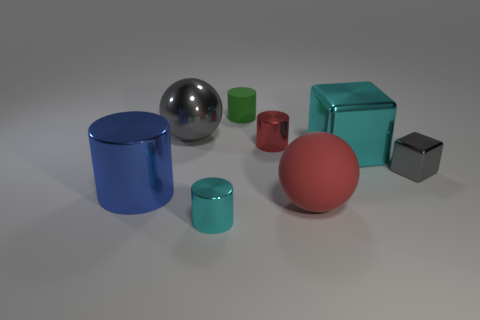Add 1 small cyan objects. How many objects exist? 9 Subtract all red cylinders. How many cylinders are left? 3 Subtract all tiny metallic blocks. Subtract all large gray shiny spheres. How many objects are left? 6 Add 7 red matte balls. How many red matte balls are left? 8 Add 1 large red rubber cubes. How many large red rubber cubes exist? 1 Subtract all gray spheres. How many spheres are left? 1 Subtract 0 yellow cylinders. How many objects are left? 8 Subtract all spheres. How many objects are left? 6 Subtract 3 cylinders. How many cylinders are left? 1 Subtract all green spheres. Subtract all purple cylinders. How many spheres are left? 2 